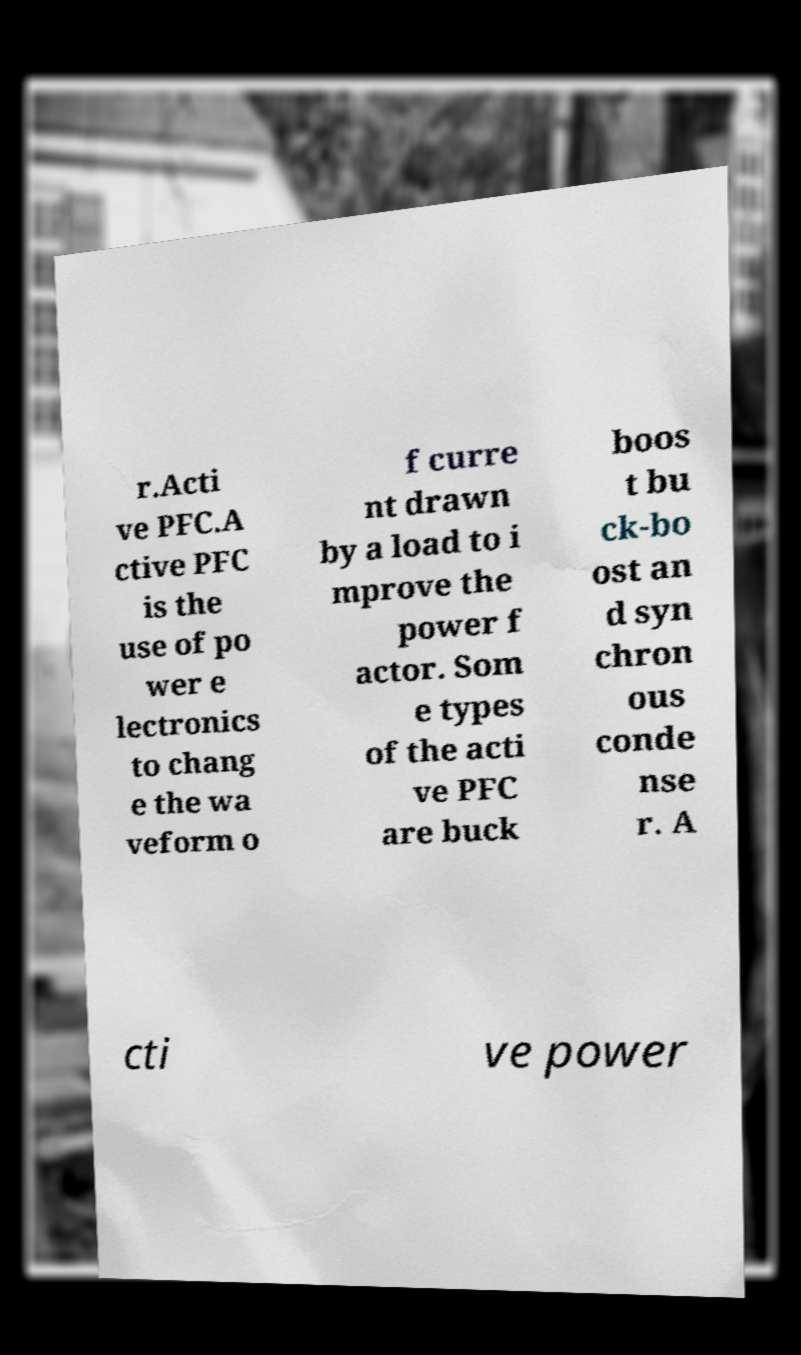Can you read and provide the text displayed in the image?This photo seems to have some interesting text. Can you extract and type it out for me? r.Acti ve PFC.A ctive PFC is the use of po wer e lectronics to chang e the wa veform o f curre nt drawn by a load to i mprove the power f actor. Som e types of the acti ve PFC are buck boos t bu ck-bo ost an d syn chron ous conde nse r. A cti ve power 